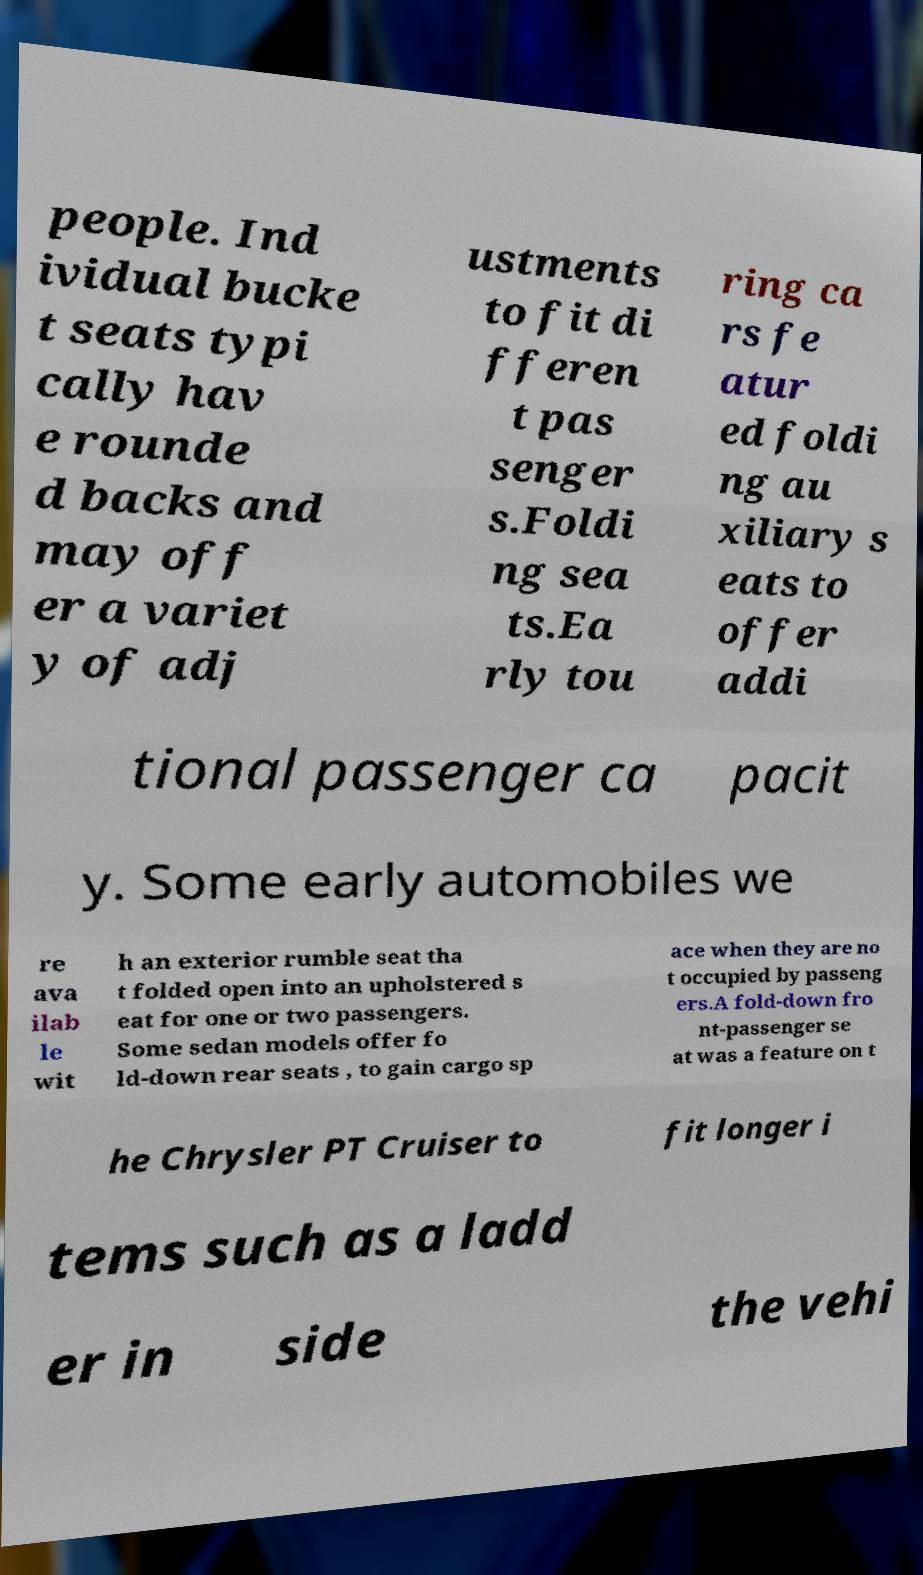Could you assist in decoding the text presented in this image and type it out clearly? people. Ind ividual bucke t seats typi cally hav e rounde d backs and may off er a variet y of adj ustments to fit di fferen t pas senger s.Foldi ng sea ts.Ea rly tou ring ca rs fe atur ed foldi ng au xiliary s eats to offer addi tional passenger ca pacit y. Some early automobiles we re ava ilab le wit h an exterior rumble seat tha t folded open into an upholstered s eat for one or two passengers. Some sedan models offer fo ld-down rear seats , to gain cargo sp ace when they are no t occupied by passeng ers.A fold-down fro nt-passenger se at was a feature on t he Chrysler PT Cruiser to fit longer i tems such as a ladd er in side the vehi 